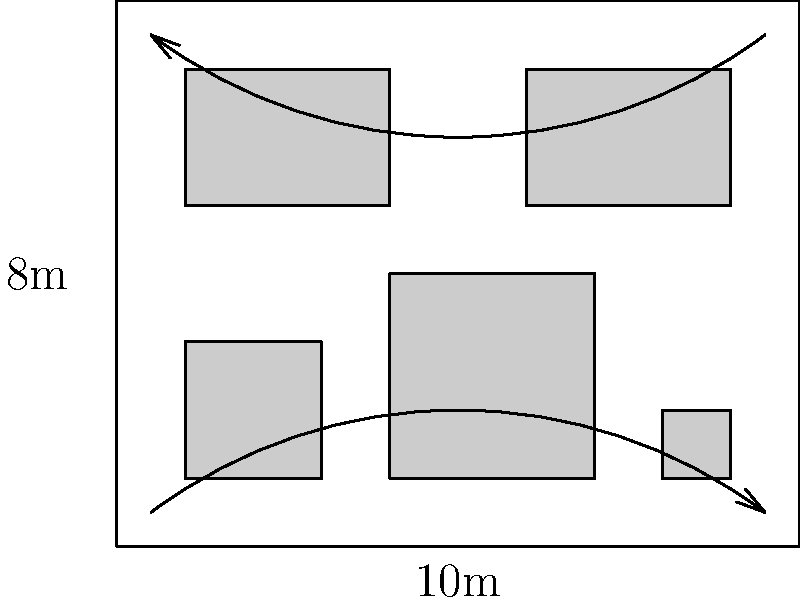As a philanthropist organizing an art exhibition, you're presented with a rectangular gallery space measuring 10m by 8m. The space contains five artworks of varying sizes, as shown in the floor plan. Considering that visitors need an average of 2 square meters of space to view each artwork comfortably and move between them, estimate the maximum number of visitors that can be accommodated in the gallery at one time while maintaining a pleasant viewing experience. To estimate the maximum number of visitors, we need to follow these steps:

1. Calculate the total area of the gallery:
   $A_{total} = 10m \times 8m = 80m^2$

2. Calculate the total area occupied by artworks:
   Artwork 1: $2m \times 2m = 4m^2$
   Artwork 2: $3m \times 3m = 9m^2$
   Artwork 3: $1m \times 1m = 1m^2$
   Artwork 4: $3m \times 2m = 6m^2$
   Artwork 5: $3m \times 2m = 6m^2$
   $A_{artworks} = 4 + 9 + 1 + 6 + 6 = 26m^2$

3. Calculate the available space for visitors:
   $A_{available} = A_{total} - A_{artworks} = 80m^2 - 26m^2 = 54m^2$

4. Determine the space required per visitor:
   Each visitor needs 2 square meters of space.

5. Calculate the maximum number of visitors:
   $N_{visitors} = \frac{A_{available}}{2m^2 \text{ per visitor}} = \frac{54m^2}{2m^2} = 27$

Therefore, the gallery can accommodate a maximum of 27 visitors while maintaining a comfortable viewing experience.
Answer: 27 visitors 